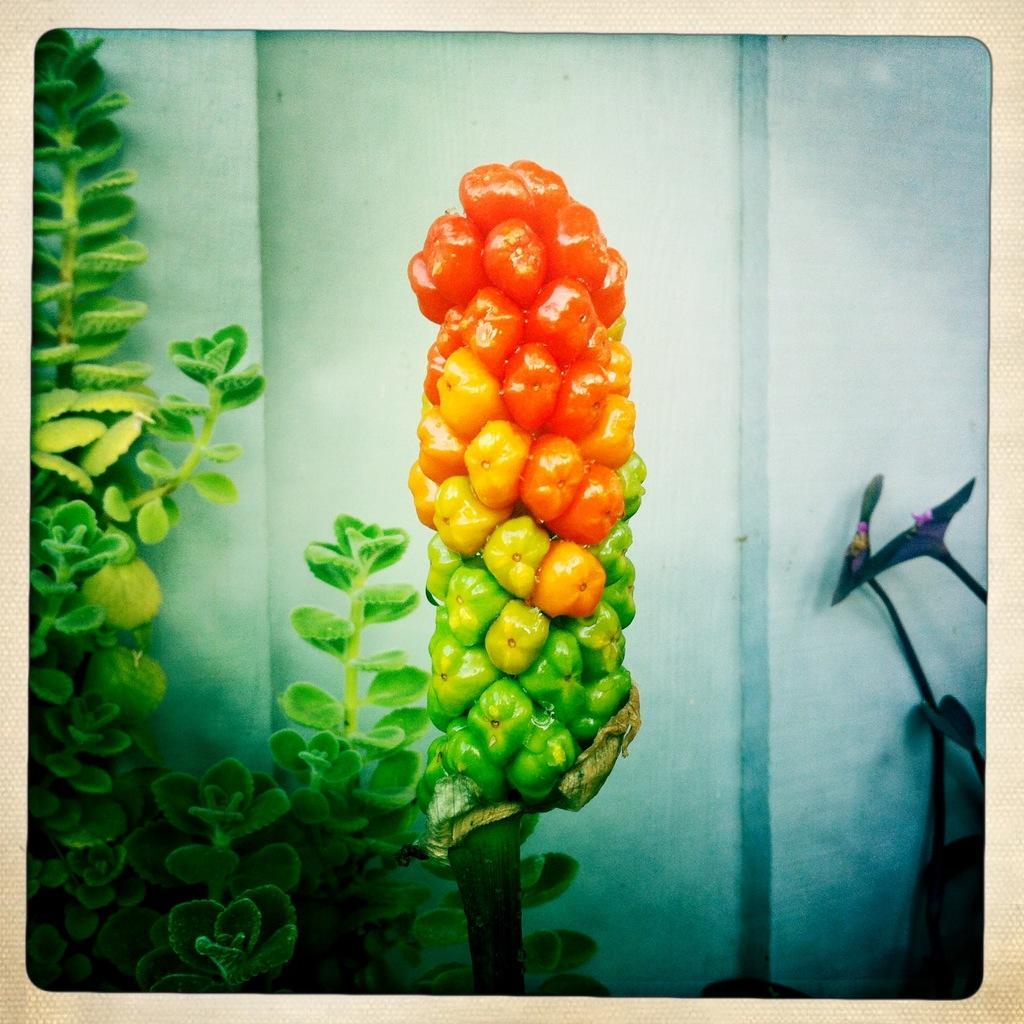Can you describe this image briefly? It is an edited image, there are many tomatoes attached with one another like a pole and on the left side there are some plants and in the background there is a wall and on the right side two sticks are kept in front of the wall. 